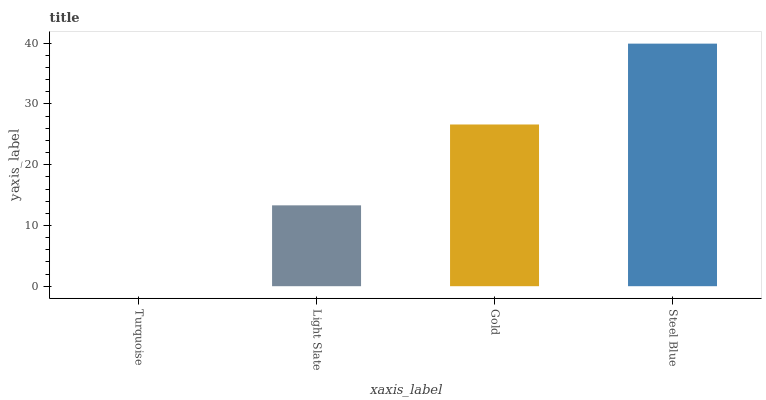Is Turquoise the minimum?
Answer yes or no. Yes. Is Steel Blue the maximum?
Answer yes or no. Yes. Is Light Slate the minimum?
Answer yes or no. No. Is Light Slate the maximum?
Answer yes or no. No. Is Light Slate greater than Turquoise?
Answer yes or no. Yes. Is Turquoise less than Light Slate?
Answer yes or no. Yes. Is Turquoise greater than Light Slate?
Answer yes or no. No. Is Light Slate less than Turquoise?
Answer yes or no. No. Is Gold the high median?
Answer yes or no. Yes. Is Light Slate the low median?
Answer yes or no. Yes. Is Steel Blue the high median?
Answer yes or no. No. Is Turquoise the low median?
Answer yes or no. No. 